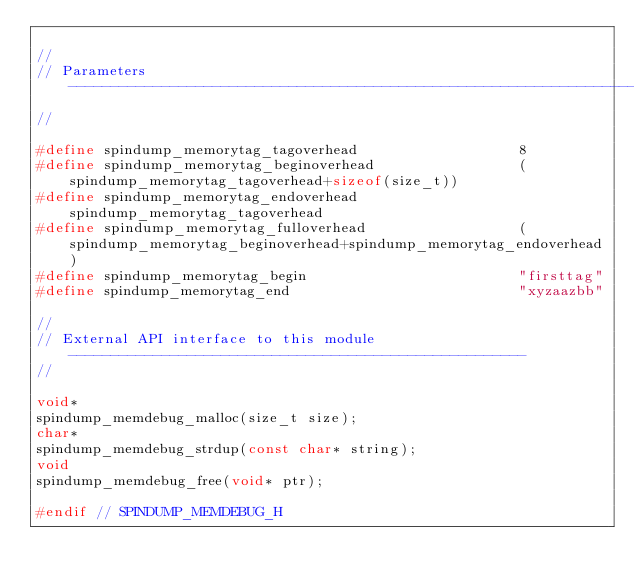Convert code to text. <code><loc_0><loc_0><loc_500><loc_500><_C_>
//
// Parameters ---------------------------------------------------------------------------------
//

#define spindump_memorytag_tagoverhead                   8
#define spindump_memorytag_beginoverhead                 (spindump_memorytag_tagoverhead+sizeof(size_t))
#define spindump_memorytag_endoverhead                   spindump_memorytag_tagoverhead
#define spindump_memorytag_fulloverhead                  (spindump_memorytag_beginoverhead+spindump_memorytag_endoverhead)
#define spindump_memorytag_begin                         "firsttag"
#define spindump_memorytag_end                           "xyzaazbb"

//
// External API interface to this module ------------------------------------------------------
//

void*
spindump_memdebug_malloc(size_t size);
char*
spindump_memdebug_strdup(const char* string);
void
spindump_memdebug_free(void* ptr);

#endif // SPINDUMP_MEMDEBUG_H
</code> 